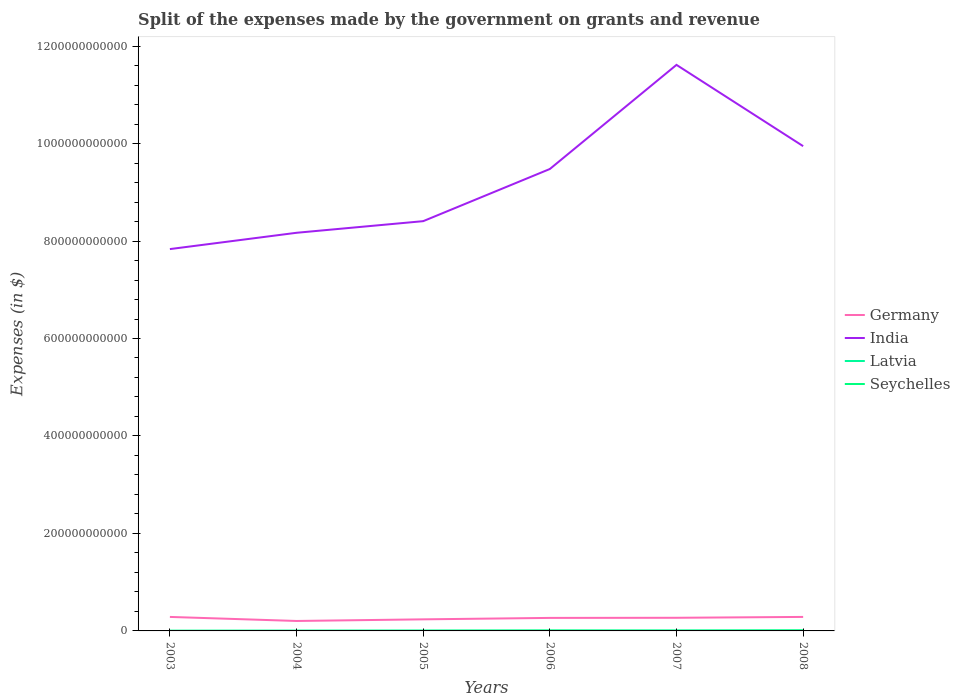Across all years, what is the maximum expenses made by the government on grants and revenue in India?
Provide a short and direct response. 7.83e+11. What is the total expenses made by the government on grants and revenue in Germany in the graph?
Your response must be concise. -4.98e+09. What is the difference between the highest and the second highest expenses made by the government on grants and revenue in India?
Offer a very short reply. 3.78e+11. What is the difference between the highest and the lowest expenses made by the government on grants and revenue in India?
Your answer should be very brief. 3. Is the expenses made by the government on grants and revenue in India strictly greater than the expenses made by the government on grants and revenue in Germany over the years?
Your answer should be compact. No. How many lines are there?
Provide a short and direct response. 4. How many years are there in the graph?
Make the answer very short. 6. What is the difference between two consecutive major ticks on the Y-axis?
Your answer should be compact. 2.00e+11. Where does the legend appear in the graph?
Offer a very short reply. Center right. How many legend labels are there?
Your response must be concise. 4. What is the title of the graph?
Keep it short and to the point. Split of the expenses made by the government on grants and revenue. What is the label or title of the Y-axis?
Your answer should be compact. Expenses (in $). What is the Expenses (in $) of Germany in 2003?
Make the answer very short. 2.87e+1. What is the Expenses (in $) in India in 2003?
Ensure brevity in your answer.  7.83e+11. What is the Expenses (in $) of Latvia in 2003?
Make the answer very short. 2.52e+08. What is the Expenses (in $) in Seychelles in 2003?
Give a very brief answer. 2.39e+08. What is the Expenses (in $) in Germany in 2004?
Offer a terse response. 2.04e+1. What is the Expenses (in $) in India in 2004?
Provide a succinct answer. 8.17e+11. What is the Expenses (in $) of Latvia in 2004?
Keep it short and to the point. 4.03e+08. What is the Expenses (in $) of Seychelles in 2004?
Offer a terse response. 2.82e+08. What is the Expenses (in $) of Germany in 2005?
Ensure brevity in your answer.  2.37e+1. What is the Expenses (in $) in India in 2005?
Provide a succinct answer. 8.41e+11. What is the Expenses (in $) of Latvia in 2005?
Offer a terse response. 5.18e+08. What is the Expenses (in $) of Seychelles in 2005?
Offer a terse response. 4.19e+08. What is the Expenses (in $) of Germany in 2006?
Offer a very short reply. 2.67e+1. What is the Expenses (in $) of India in 2006?
Make the answer very short. 9.48e+11. What is the Expenses (in $) in Latvia in 2006?
Keep it short and to the point. 5.75e+08. What is the Expenses (in $) in Seychelles in 2006?
Provide a short and direct response. 8.11e+08. What is the Expenses (in $) in Germany in 2007?
Your response must be concise. 2.70e+1. What is the Expenses (in $) of India in 2007?
Make the answer very short. 1.16e+12. What is the Expenses (in $) in Latvia in 2007?
Provide a short and direct response. 8.10e+08. What is the Expenses (in $) of Seychelles in 2007?
Keep it short and to the point. 4.27e+08. What is the Expenses (in $) in Germany in 2008?
Offer a terse response. 2.87e+1. What is the Expenses (in $) of India in 2008?
Provide a short and direct response. 9.95e+11. What is the Expenses (in $) in Latvia in 2008?
Provide a short and direct response. 8.22e+08. What is the Expenses (in $) in Seychelles in 2008?
Offer a very short reply. 1.01e+09. Across all years, what is the maximum Expenses (in $) of Germany?
Offer a terse response. 2.87e+1. Across all years, what is the maximum Expenses (in $) in India?
Your response must be concise. 1.16e+12. Across all years, what is the maximum Expenses (in $) of Latvia?
Your answer should be compact. 8.22e+08. Across all years, what is the maximum Expenses (in $) in Seychelles?
Make the answer very short. 1.01e+09. Across all years, what is the minimum Expenses (in $) of Germany?
Keep it short and to the point. 2.04e+1. Across all years, what is the minimum Expenses (in $) in India?
Keep it short and to the point. 7.83e+11. Across all years, what is the minimum Expenses (in $) of Latvia?
Ensure brevity in your answer.  2.52e+08. Across all years, what is the minimum Expenses (in $) in Seychelles?
Provide a succinct answer. 2.39e+08. What is the total Expenses (in $) of Germany in the graph?
Give a very brief answer. 1.55e+11. What is the total Expenses (in $) in India in the graph?
Give a very brief answer. 5.54e+12. What is the total Expenses (in $) of Latvia in the graph?
Offer a very short reply. 3.38e+09. What is the total Expenses (in $) in Seychelles in the graph?
Ensure brevity in your answer.  3.19e+09. What is the difference between the Expenses (in $) in Germany in 2003 and that in 2004?
Give a very brief answer. 8.29e+09. What is the difference between the Expenses (in $) of India in 2003 and that in 2004?
Your answer should be very brief. -3.34e+1. What is the difference between the Expenses (in $) of Latvia in 2003 and that in 2004?
Make the answer very short. -1.51e+08. What is the difference between the Expenses (in $) in Seychelles in 2003 and that in 2004?
Make the answer very short. -4.30e+07. What is the difference between the Expenses (in $) in Germany in 2003 and that in 2005?
Your answer should be compact. 4.98e+09. What is the difference between the Expenses (in $) in India in 2003 and that in 2005?
Make the answer very short. -5.73e+1. What is the difference between the Expenses (in $) in Latvia in 2003 and that in 2005?
Ensure brevity in your answer.  -2.65e+08. What is the difference between the Expenses (in $) of Seychelles in 2003 and that in 2005?
Your answer should be compact. -1.80e+08. What is the difference between the Expenses (in $) in Germany in 2003 and that in 2006?
Your answer should be compact. 2.01e+09. What is the difference between the Expenses (in $) in India in 2003 and that in 2006?
Offer a very short reply. -1.64e+11. What is the difference between the Expenses (in $) of Latvia in 2003 and that in 2006?
Provide a short and direct response. -3.23e+08. What is the difference between the Expenses (in $) of Seychelles in 2003 and that in 2006?
Your answer should be compact. -5.72e+08. What is the difference between the Expenses (in $) in Germany in 2003 and that in 2007?
Provide a short and direct response. 1.77e+09. What is the difference between the Expenses (in $) in India in 2003 and that in 2007?
Offer a very short reply. -3.78e+11. What is the difference between the Expenses (in $) of Latvia in 2003 and that in 2007?
Ensure brevity in your answer.  -5.57e+08. What is the difference between the Expenses (in $) of Seychelles in 2003 and that in 2007?
Offer a terse response. -1.88e+08. What is the difference between the Expenses (in $) of India in 2003 and that in 2008?
Your response must be concise. -2.11e+11. What is the difference between the Expenses (in $) in Latvia in 2003 and that in 2008?
Your response must be concise. -5.70e+08. What is the difference between the Expenses (in $) of Seychelles in 2003 and that in 2008?
Your answer should be very brief. -7.74e+08. What is the difference between the Expenses (in $) in Germany in 2004 and that in 2005?
Provide a succinct answer. -3.31e+09. What is the difference between the Expenses (in $) of India in 2004 and that in 2005?
Your answer should be very brief. -2.38e+1. What is the difference between the Expenses (in $) in Latvia in 2004 and that in 2005?
Your response must be concise. -1.14e+08. What is the difference between the Expenses (in $) in Seychelles in 2004 and that in 2005?
Your answer should be very brief. -1.37e+08. What is the difference between the Expenses (in $) in Germany in 2004 and that in 2006?
Your answer should be very brief. -6.28e+09. What is the difference between the Expenses (in $) of India in 2004 and that in 2006?
Keep it short and to the point. -1.31e+11. What is the difference between the Expenses (in $) in Latvia in 2004 and that in 2006?
Keep it short and to the point. -1.72e+08. What is the difference between the Expenses (in $) in Seychelles in 2004 and that in 2006?
Make the answer very short. -5.29e+08. What is the difference between the Expenses (in $) of Germany in 2004 and that in 2007?
Ensure brevity in your answer.  -6.52e+09. What is the difference between the Expenses (in $) of India in 2004 and that in 2007?
Make the answer very short. -3.45e+11. What is the difference between the Expenses (in $) in Latvia in 2004 and that in 2007?
Give a very brief answer. -4.06e+08. What is the difference between the Expenses (in $) in Seychelles in 2004 and that in 2007?
Provide a succinct answer. -1.45e+08. What is the difference between the Expenses (in $) in Germany in 2004 and that in 2008?
Ensure brevity in your answer.  -8.29e+09. What is the difference between the Expenses (in $) in India in 2004 and that in 2008?
Keep it short and to the point. -1.78e+11. What is the difference between the Expenses (in $) in Latvia in 2004 and that in 2008?
Provide a succinct answer. -4.19e+08. What is the difference between the Expenses (in $) of Seychelles in 2004 and that in 2008?
Ensure brevity in your answer.  -7.31e+08. What is the difference between the Expenses (in $) of Germany in 2005 and that in 2006?
Ensure brevity in your answer.  -2.97e+09. What is the difference between the Expenses (in $) in India in 2005 and that in 2006?
Keep it short and to the point. -1.07e+11. What is the difference between the Expenses (in $) in Latvia in 2005 and that in 2006?
Offer a very short reply. -5.76e+07. What is the difference between the Expenses (in $) of Seychelles in 2005 and that in 2006?
Your answer should be very brief. -3.92e+08. What is the difference between the Expenses (in $) of Germany in 2005 and that in 2007?
Make the answer very short. -3.21e+09. What is the difference between the Expenses (in $) of India in 2005 and that in 2007?
Your answer should be compact. -3.21e+11. What is the difference between the Expenses (in $) of Latvia in 2005 and that in 2007?
Provide a short and direct response. -2.92e+08. What is the difference between the Expenses (in $) in Seychelles in 2005 and that in 2007?
Your answer should be compact. -7.91e+06. What is the difference between the Expenses (in $) of Germany in 2005 and that in 2008?
Give a very brief answer. -4.98e+09. What is the difference between the Expenses (in $) in India in 2005 and that in 2008?
Offer a terse response. -1.54e+11. What is the difference between the Expenses (in $) in Latvia in 2005 and that in 2008?
Make the answer very short. -3.04e+08. What is the difference between the Expenses (in $) in Seychelles in 2005 and that in 2008?
Your answer should be very brief. -5.94e+08. What is the difference between the Expenses (in $) of Germany in 2006 and that in 2007?
Your response must be concise. -2.40e+08. What is the difference between the Expenses (in $) of India in 2006 and that in 2007?
Keep it short and to the point. -2.14e+11. What is the difference between the Expenses (in $) of Latvia in 2006 and that in 2007?
Provide a short and direct response. -2.34e+08. What is the difference between the Expenses (in $) in Seychelles in 2006 and that in 2007?
Provide a short and direct response. 3.84e+08. What is the difference between the Expenses (in $) in Germany in 2006 and that in 2008?
Make the answer very short. -2.01e+09. What is the difference between the Expenses (in $) in India in 2006 and that in 2008?
Give a very brief answer. -4.69e+1. What is the difference between the Expenses (in $) of Latvia in 2006 and that in 2008?
Offer a terse response. -2.47e+08. What is the difference between the Expenses (in $) of Seychelles in 2006 and that in 2008?
Provide a succinct answer. -2.02e+08. What is the difference between the Expenses (in $) in Germany in 2007 and that in 2008?
Your answer should be very brief. -1.77e+09. What is the difference between the Expenses (in $) of India in 2007 and that in 2008?
Your answer should be compact. 1.67e+11. What is the difference between the Expenses (in $) in Latvia in 2007 and that in 2008?
Ensure brevity in your answer.  -1.25e+07. What is the difference between the Expenses (in $) of Seychelles in 2007 and that in 2008?
Provide a short and direct response. -5.86e+08. What is the difference between the Expenses (in $) in Germany in 2003 and the Expenses (in $) in India in 2004?
Offer a very short reply. -7.88e+11. What is the difference between the Expenses (in $) of Germany in 2003 and the Expenses (in $) of Latvia in 2004?
Your answer should be compact. 2.83e+1. What is the difference between the Expenses (in $) in Germany in 2003 and the Expenses (in $) in Seychelles in 2004?
Provide a short and direct response. 2.84e+1. What is the difference between the Expenses (in $) of India in 2003 and the Expenses (in $) of Latvia in 2004?
Your answer should be very brief. 7.83e+11. What is the difference between the Expenses (in $) of India in 2003 and the Expenses (in $) of Seychelles in 2004?
Provide a short and direct response. 7.83e+11. What is the difference between the Expenses (in $) of Latvia in 2003 and the Expenses (in $) of Seychelles in 2004?
Make the answer very short. -2.95e+07. What is the difference between the Expenses (in $) of Germany in 2003 and the Expenses (in $) of India in 2005?
Offer a very short reply. -8.12e+11. What is the difference between the Expenses (in $) of Germany in 2003 and the Expenses (in $) of Latvia in 2005?
Make the answer very short. 2.82e+1. What is the difference between the Expenses (in $) of Germany in 2003 and the Expenses (in $) of Seychelles in 2005?
Keep it short and to the point. 2.83e+1. What is the difference between the Expenses (in $) in India in 2003 and the Expenses (in $) in Latvia in 2005?
Offer a very short reply. 7.83e+11. What is the difference between the Expenses (in $) of India in 2003 and the Expenses (in $) of Seychelles in 2005?
Offer a terse response. 7.83e+11. What is the difference between the Expenses (in $) in Latvia in 2003 and the Expenses (in $) in Seychelles in 2005?
Provide a succinct answer. -1.66e+08. What is the difference between the Expenses (in $) of Germany in 2003 and the Expenses (in $) of India in 2006?
Provide a short and direct response. -9.19e+11. What is the difference between the Expenses (in $) of Germany in 2003 and the Expenses (in $) of Latvia in 2006?
Your answer should be compact. 2.81e+1. What is the difference between the Expenses (in $) of Germany in 2003 and the Expenses (in $) of Seychelles in 2006?
Give a very brief answer. 2.79e+1. What is the difference between the Expenses (in $) in India in 2003 and the Expenses (in $) in Latvia in 2006?
Ensure brevity in your answer.  7.83e+11. What is the difference between the Expenses (in $) of India in 2003 and the Expenses (in $) of Seychelles in 2006?
Keep it short and to the point. 7.83e+11. What is the difference between the Expenses (in $) in Latvia in 2003 and the Expenses (in $) in Seychelles in 2006?
Your response must be concise. -5.59e+08. What is the difference between the Expenses (in $) of Germany in 2003 and the Expenses (in $) of India in 2007?
Your answer should be compact. -1.13e+12. What is the difference between the Expenses (in $) of Germany in 2003 and the Expenses (in $) of Latvia in 2007?
Offer a terse response. 2.79e+1. What is the difference between the Expenses (in $) in Germany in 2003 and the Expenses (in $) in Seychelles in 2007?
Offer a terse response. 2.83e+1. What is the difference between the Expenses (in $) in India in 2003 and the Expenses (in $) in Latvia in 2007?
Make the answer very short. 7.83e+11. What is the difference between the Expenses (in $) of India in 2003 and the Expenses (in $) of Seychelles in 2007?
Keep it short and to the point. 7.83e+11. What is the difference between the Expenses (in $) of Latvia in 2003 and the Expenses (in $) of Seychelles in 2007?
Provide a succinct answer. -1.74e+08. What is the difference between the Expenses (in $) in Germany in 2003 and the Expenses (in $) in India in 2008?
Give a very brief answer. -9.66e+11. What is the difference between the Expenses (in $) in Germany in 2003 and the Expenses (in $) in Latvia in 2008?
Provide a short and direct response. 2.79e+1. What is the difference between the Expenses (in $) of Germany in 2003 and the Expenses (in $) of Seychelles in 2008?
Offer a very short reply. 2.77e+1. What is the difference between the Expenses (in $) in India in 2003 and the Expenses (in $) in Latvia in 2008?
Offer a terse response. 7.83e+11. What is the difference between the Expenses (in $) of India in 2003 and the Expenses (in $) of Seychelles in 2008?
Offer a very short reply. 7.82e+11. What is the difference between the Expenses (in $) in Latvia in 2003 and the Expenses (in $) in Seychelles in 2008?
Give a very brief answer. -7.61e+08. What is the difference between the Expenses (in $) of Germany in 2004 and the Expenses (in $) of India in 2005?
Your response must be concise. -8.20e+11. What is the difference between the Expenses (in $) in Germany in 2004 and the Expenses (in $) in Latvia in 2005?
Provide a succinct answer. 1.99e+1. What is the difference between the Expenses (in $) of Germany in 2004 and the Expenses (in $) of Seychelles in 2005?
Your response must be concise. 2.00e+1. What is the difference between the Expenses (in $) of India in 2004 and the Expenses (in $) of Latvia in 2005?
Make the answer very short. 8.16e+11. What is the difference between the Expenses (in $) of India in 2004 and the Expenses (in $) of Seychelles in 2005?
Offer a very short reply. 8.16e+11. What is the difference between the Expenses (in $) in Latvia in 2004 and the Expenses (in $) in Seychelles in 2005?
Offer a terse response. -1.53e+07. What is the difference between the Expenses (in $) of Germany in 2004 and the Expenses (in $) of India in 2006?
Ensure brevity in your answer.  -9.27e+11. What is the difference between the Expenses (in $) of Germany in 2004 and the Expenses (in $) of Latvia in 2006?
Your answer should be compact. 1.99e+1. What is the difference between the Expenses (in $) of Germany in 2004 and the Expenses (in $) of Seychelles in 2006?
Make the answer very short. 1.96e+1. What is the difference between the Expenses (in $) of India in 2004 and the Expenses (in $) of Latvia in 2006?
Give a very brief answer. 8.16e+11. What is the difference between the Expenses (in $) of India in 2004 and the Expenses (in $) of Seychelles in 2006?
Give a very brief answer. 8.16e+11. What is the difference between the Expenses (in $) of Latvia in 2004 and the Expenses (in $) of Seychelles in 2006?
Keep it short and to the point. -4.08e+08. What is the difference between the Expenses (in $) of Germany in 2004 and the Expenses (in $) of India in 2007?
Ensure brevity in your answer.  -1.14e+12. What is the difference between the Expenses (in $) of Germany in 2004 and the Expenses (in $) of Latvia in 2007?
Your answer should be very brief. 1.96e+1. What is the difference between the Expenses (in $) of Germany in 2004 and the Expenses (in $) of Seychelles in 2007?
Your response must be concise. 2.00e+1. What is the difference between the Expenses (in $) in India in 2004 and the Expenses (in $) in Latvia in 2007?
Offer a terse response. 8.16e+11. What is the difference between the Expenses (in $) of India in 2004 and the Expenses (in $) of Seychelles in 2007?
Make the answer very short. 8.16e+11. What is the difference between the Expenses (in $) of Latvia in 2004 and the Expenses (in $) of Seychelles in 2007?
Your answer should be compact. -2.32e+07. What is the difference between the Expenses (in $) of Germany in 2004 and the Expenses (in $) of India in 2008?
Provide a short and direct response. -9.74e+11. What is the difference between the Expenses (in $) of Germany in 2004 and the Expenses (in $) of Latvia in 2008?
Offer a terse response. 1.96e+1. What is the difference between the Expenses (in $) of Germany in 2004 and the Expenses (in $) of Seychelles in 2008?
Your answer should be compact. 1.94e+1. What is the difference between the Expenses (in $) of India in 2004 and the Expenses (in $) of Latvia in 2008?
Your answer should be compact. 8.16e+11. What is the difference between the Expenses (in $) in India in 2004 and the Expenses (in $) in Seychelles in 2008?
Offer a very short reply. 8.16e+11. What is the difference between the Expenses (in $) in Latvia in 2004 and the Expenses (in $) in Seychelles in 2008?
Your answer should be compact. -6.09e+08. What is the difference between the Expenses (in $) in Germany in 2005 and the Expenses (in $) in India in 2006?
Give a very brief answer. -9.24e+11. What is the difference between the Expenses (in $) in Germany in 2005 and the Expenses (in $) in Latvia in 2006?
Give a very brief answer. 2.32e+1. What is the difference between the Expenses (in $) in Germany in 2005 and the Expenses (in $) in Seychelles in 2006?
Your answer should be compact. 2.29e+1. What is the difference between the Expenses (in $) in India in 2005 and the Expenses (in $) in Latvia in 2006?
Your response must be concise. 8.40e+11. What is the difference between the Expenses (in $) of India in 2005 and the Expenses (in $) of Seychelles in 2006?
Make the answer very short. 8.40e+11. What is the difference between the Expenses (in $) in Latvia in 2005 and the Expenses (in $) in Seychelles in 2006?
Offer a very short reply. -2.93e+08. What is the difference between the Expenses (in $) of Germany in 2005 and the Expenses (in $) of India in 2007?
Give a very brief answer. -1.14e+12. What is the difference between the Expenses (in $) in Germany in 2005 and the Expenses (in $) in Latvia in 2007?
Provide a succinct answer. 2.29e+1. What is the difference between the Expenses (in $) in Germany in 2005 and the Expenses (in $) in Seychelles in 2007?
Make the answer very short. 2.33e+1. What is the difference between the Expenses (in $) in India in 2005 and the Expenses (in $) in Latvia in 2007?
Make the answer very short. 8.40e+11. What is the difference between the Expenses (in $) of India in 2005 and the Expenses (in $) of Seychelles in 2007?
Keep it short and to the point. 8.40e+11. What is the difference between the Expenses (in $) in Latvia in 2005 and the Expenses (in $) in Seychelles in 2007?
Ensure brevity in your answer.  9.10e+07. What is the difference between the Expenses (in $) in Germany in 2005 and the Expenses (in $) in India in 2008?
Provide a succinct answer. -9.71e+11. What is the difference between the Expenses (in $) of Germany in 2005 and the Expenses (in $) of Latvia in 2008?
Make the answer very short. 2.29e+1. What is the difference between the Expenses (in $) in Germany in 2005 and the Expenses (in $) in Seychelles in 2008?
Give a very brief answer. 2.27e+1. What is the difference between the Expenses (in $) in India in 2005 and the Expenses (in $) in Latvia in 2008?
Your answer should be very brief. 8.40e+11. What is the difference between the Expenses (in $) in India in 2005 and the Expenses (in $) in Seychelles in 2008?
Your answer should be very brief. 8.40e+11. What is the difference between the Expenses (in $) of Latvia in 2005 and the Expenses (in $) of Seychelles in 2008?
Give a very brief answer. -4.95e+08. What is the difference between the Expenses (in $) of Germany in 2006 and the Expenses (in $) of India in 2007?
Provide a succinct answer. -1.13e+12. What is the difference between the Expenses (in $) of Germany in 2006 and the Expenses (in $) of Latvia in 2007?
Your response must be concise. 2.59e+1. What is the difference between the Expenses (in $) in Germany in 2006 and the Expenses (in $) in Seychelles in 2007?
Your response must be concise. 2.63e+1. What is the difference between the Expenses (in $) in India in 2006 and the Expenses (in $) in Latvia in 2007?
Make the answer very short. 9.47e+11. What is the difference between the Expenses (in $) of India in 2006 and the Expenses (in $) of Seychelles in 2007?
Provide a short and direct response. 9.47e+11. What is the difference between the Expenses (in $) in Latvia in 2006 and the Expenses (in $) in Seychelles in 2007?
Your answer should be compact. 1.49e+08. What is the difference between the Expenses (in $) of Germany in 2006 and the Expenses (in $) of India in 2008?
Provide a succinct answer. -9.68e+11. What is the difference between the Expenses (in $) of Germany in 2006 and the Expenses (in $) of Latvia in 2008?
Give a very brief answer. 2.59e+1. What is the difference between the Expenses (in $) in Germany in 2006 and the Expenses (in $) in Seychelles in 2008?
Make the answer very short. 2.57e+1. What is the difference between the Expenses (in $) of India in 2006 and the Expenses (in $) of Latvia in 2008?
Keep it short and to the point. 9.47e+11. What is the difference between the Expenses (in $) of India in 2006 and the Expenses (in $) of Seychelles in 2008?
Your answer should be compact. 9.47e+11. What is the difference between the Expenses (in $) in Latvia in 2006 and the Expenses (in $) in Seychelles in 2008?
Keep it short and to the point. -4.38e+08. What is the difference between the Expenses (in $) of Germany in 2007 and the Expenses (in $) of India in 2008?
Give a very brief answer. -9.68e+11. What is the difference between the Expenses (in $) of Germany in 2007 and the Expenses (in $) of Latvia in 2008?
Provide a succinct answer. 2.61e+1. What is the difference between the Expenses (in $) in Germany in 2007 and the Expenses (in $) in Seychelles in 2008?
Provide a succinct answer. 2.59e+1. What is the difference between the Expenses (in $) of India in 2007 and the Expenses (in $) of Latvia in 2008?
Keep it short and to the point. 1.16e+12. What is the difference between the Expenses (in $) of India in 2007 and the Expenses (in $) of Seychelles in 2008?
Give a very brief answer. 1.16e+12. What is the difference between the Expenses (in $) of Latvia in 2007 and the Expenses (in $) of Seychelles in 2008?
Provide a short and direct response. -2.03e+08. What is the average Expenses (in $) of Germany per year?
Your answer should be compact. 2.59e+1. What is the average Expenses (in $) in India per year?
Provide a short and direct response. 9.24e+11. What is the average Expenses (in $) in Latvia per year?
Your answer should be very brief. 5.63e+08. What is the average Expenses (in $) of Seychelles per year?
Offer a terse response. 5.32e+08. In the year 2003, what is the difference between the Expenses (in $) of Germany and Expenses (in $) of India?
Give a very brief answer. -7.55e+11. In the year 2003, what is the difference between the Expenses (in $) in Germany and Expenses (in $) in Latvia?
Offer a very short reply. 2.85e+1. In the year 2003, what is the difference between the Expenses (in $) in Germany and Expenses (in $) in Seychelles?
Give a very brief answer. 2.85e+1. In the year 2003, what is the difference between the Expenses (in $) in India and Expenses (in $) in Latvia?
Your response must be concise. 7.83e+11. In the year 2003, what is the difference between the Expenses (in $) in India and Expenses (in $) in Seychelles?
Your response must be concise. 7.83e+11. In the year 2003, what is the difference between the Expenses (in $) in Latvia and Expenses (in $) in Seychelles?
Your answer should be compact. 1.35e+07. In the year 2004, what is the difference between the Expenses (in $) in Germany and Expenses (in $) in India?
Make the answer very short. -7.96e+11. In the year 2004, what is the difference between the Expenses (in $) in Germany and Expenses (in $) in Latvia?
Your response must be concise. 2.00e+1. In the year 2004, what is the difference between the Expenses (in $) of Germany and Expenses (in $) of Seychelles?
Provide a succinct answer. 2.01e+1. In the year 2004, what is the difference between the Expenses (in $) in India and Expenses (in $) in Latvia?
Provide a short and direct response. 8.17e+11. In the year 2004, what is the difference between the Expenses (in $) in India and Expenses (in $) in Seychelles?
Keep it short and to the point. 8.17e+11. In the year 2004, what is the difference between the Expenses (in $) in Latvia and Expenses (in $) in Seychelles?
Offer a very short reply. 1.22e+08. In the year 2005, what is the difference between the Expenses (in $) in Germany and Expenses (in $) in India?
Provide a short and direct response. -8.17e+11. In the year 2005, what is the difference between the Expenses (in $) in Germany and Expenses (in $) in Latvia?
Keep it short and to the point. 2.32e+1. In the year 2005, what is the difference between the Expenses (in $) in Germany and Expenses (in $) in Seychelles?
Offer a terse response. 2.33e+1. In the year 2005, what is the difference between the Expenses (in $) of India and Expenses (in $) of Latvia?
Provide a short and direct response. 8.40e+11. In the year 2005, what is the difference between the Expenses (in $) in India and Expenses (in $) in Seychelles?
Your answer should be compact. 8.40e+11. In the year 2005, what is the difference between the Expenses (in $) of Latvia and Expenses (in $) of Seychelles?
Make the answer very short. 9.89e+07. In the year 2006, what is the difference between the Expenses (in $) in Germany and Expenses (in $) in India?
Your response must be concise. -9.21e+11. In the year 2006, what is the difference between the Expenses (in $) in Germany and Expenses (in $) in Latvia?
Give a very brief answer. 2.61e+1. In the year 2006, what is the difference between the Expenses (in $) in Germany and Expenses (in $) in Seychelles?
Your response must be concise. 2.59e+1. In the year 2006, what is the difference between the Expenses (in $) of India and Expenses (in $) of Latvia?
Your answer should be compact. 9.47e+11. In the year 2006, what is the difference between the Expenses (in $) of India and Expenses (in $) of Seychelles?
Provide a short and direct response. 9.47e+11. In the year 2006, what is the difference between the Expenses (in $) of Latvia and Expenses (in $) of Seychelles?
Make the answer very short. -2.36e+08. In the year 2007, what is the difference between the Expenses (in $) of Germany and Expenses (in $) of India?
Make the answer very short. -1.13e+12. In the year 2007, what is the difference between the Expenses (in $) of Germany and Expenses (in $) of Latvia?
Your answer should be compact. 2.61e+1. In the year 2007, what is the difference between the Expenses (in $) in Germany and Expenses (in $) in Seychelles?
Your answer should be very brief. 2.65e+1. In the year 2007, what is the difference between the Expenses (in $) in India and Expenses (in $) in Latvia?
Provide a short and direct response. 1.16e+12. In the year 2007, what is the difference between the Expenses (in $) of India and Expenses (in $) of Seychelles?
Provide a short and direct response. 1.16e+12. In the year 2007, what is the difference between the Expenses (in $) of Latvia and Expenses (in $) of Seychelles?
Offer a very short reply. 3.83e+08. In the year 2008, what is the difference between the Expenses (in $) in Germany and Expenses (in $) in India?
Give a very brief answer. -9.66e+11. In the year 2008, what is the difference between the Expenses (in $) in Germany and Expenses (in $) in Latvia?
Your response must be concise. 2.79e+1. In the year 2008, what is the difference between the Expenses (in $) in Germany and Expenses (in $) in Seychelles?
Your answer should be compact. 2.77e+1. In the year 2008, what is the difference between the Expenses (in $) of India and Expenses (in $) of Latvia?
Your answer should be very brief. 9.94e+11. In the year 2008, what is the difference between the Expenses (in $) of India and Expenses (in $) of Seychelles?
Offer a very short reply. 9.94e+11. In the year 2008, what is the difference between the Expenses (in $) in Latvia and Expenses (in $) in Seychelles?
Your answer should be very brief. -1.91e+08. What is the ratio of the Expenses (in $) in Germany in 2003 to that in 2004?
Offer a terse response. 1.41. What is the ratio of the Expenses (in $) in India in 2003 to that in 2004?
Offer a terse response. 0.96. What is the ratio of the Expenses (in $) of Latvia in 2003 to that in 2004?
Provide a short and direct response. 0.63. What is the ratio of the Expenses (in $) of Seychelles in 2003 to that in 2004?
Give a very brief answer. 0.85. What is the ratio of the Expenses (in $) in Germany in 2003 to that in 2005?
Offer a very short reply. 1.21. What is the ratio of the Expenses (in $) of India in 2003 to that in 2005?
Offer a very short reply. 0.93. What is the ratio of the Expenses (in $) in Latvia in 2003 to that in 2005?
Your response must be concise. 0.49. What is the ratio of the Expenses (in $) in Seychelles in 2003 to that in 2005?
Make the answer very short. 0.57. What is the ratio of the Expenses (in $) of Germany in 2003 to that in 2006?
Your response must be concise. 1.08. What is the ratio of the Expenses (in $) of India in 2003 to that in 2006?
Provide a short and direct response. 0.83. What is the ratio of the Expenses (in $) in Latvia in 2003 to that in 2006?
Keep it short and to the point. 0.44. What is the ratio of the Expenses (in $) of Seychelles in 2003 to that in 2006?
Provide a succinct answer. 0.29. What is the ratio of the Expenses (in $) in Germany in 2003 to that in 2007?
Provide a succinct answer. 1.07. What is the ratio of the Expenses (in $) of India in 2003 to that in 2007?
Provide a short and direct response. 0.67. What is the ratio of the Expenses (in $) of Latvia in 2003 to that in 2007?
Provide a succinct answer. 0.31. What is the ratio of the Expenses (in $) in Seychelles in 2003 to that in 2007?
Ensure brevity in your answer.  0.56. What is the ratio of the Expenses (in $) in India in 2003 to that in 2008?
Your answer should be compact. 0.79. What is the ratio of the Expenses (in $) in Latvia in 2003 to that in 2008?
Make the answer very short. 0.31. What is the ratio of the Expenses (in $) of Seychelles in 2003 to that in 2008?
Offer a very short reply. 0.24. What is the ratio of the Expenses (in $) of Germany in 2004 to that in 2005?
Your answer should be very brief. 0.86. What is the ratio of the Expenses (in $) of India in 2004 to that in 2005?
Provide a short and direct response. 0.97. What is the ratio of the Expenses (in $) in Latvia in 2004 to that in 2005?
Provide a succinct answer. 0.78. What is the ratio of the Expenses (in $) in Seychelles in 2004 to that in 2005?
Your response must be concise. 0.67. What is the ratio of the Expenses (in $) of Germany in 2004 to that in 2006?
Provide a short and direct response. 0.76. What is the ratio of the Expenses (in $) of India in 2004 to that in 2006?
Offer a very short reply. 0.86. What is the ratio of the Expenses (in $) in Latvia in 2004 to that in 2006?
Provide a succinct answer. 0.7. What is the ratio of the Expenses (in $) in Seychelles in 2004 to that in 2006?
Give a very brief answer. 0.35. What is the ratio of the Expenses (in $) of Germany in 2004 to that in 2007?
Your response must be concise. 0.76. What is the ratio of the Expenses (in $) in India in 2004 to that in 2007?
Offer a terse response. 0.7. What is the ratio of the Expenses (in $) of Latvia in 2004 to that in 2007?
Offer a very short reply. 0.5. What is the ratio of the Expenses (in $) in Seychelles in 2004 to that in 2007?
Your answer should be compact. 0.66. What is the ratio of the Expenses (in $) of Germany in 2004 to that in 2008?
Your answer should be very brief. 0.71. What is the ratio of the Expenses (in $) in India in 2004 to that in 2008?
Make the answer very short. 0.82. What is the ratio of the Expenses (in $) in Latvia in 2004 to that in 2008?
Give a very brief answer. 0.49. What is the ratio of the Expenses (in $) of Seychelles in 2004 to that in 2008?
Provide a short and direct response. 0.28. What is the ratio of the Expenses (in $) of Germany in 2005 to that in 2006?
Your answer should be very brief. 0.89. What is the ratio of the Expenses (in $) in India in 2005 to that in 2006?
Ensure brevity in your answer.  0.89. What is the ratio of the Expenses (in $) of Latvia in 2005 to that in 2006?
Offer a terse response. 0.9. What is the ratio of the Expenses (in $) in Seychelles in 2005 to that in 2006?
Provide a succinct answer. 0.52. What is the ratio of the Expenses (in $) in Germany in 2005 to that in 2007?
Ensure brevity in your answer.  0.88. What is the ratio of the Expenses (in $) of India in 2005 to that in 2007?
Make the answer very short. 0.72. What is the ratio of the Expenses (in $) of Latvia in 2005 to that in 2007?
Ensure brevity in your answer.  0.64. What is the ratio of the Expenses (in $) in Seychelles in 2005 to that in 2007?
Keep it short and to the point. 0.98. What is the ratio of the Expenses (in $) of Germany in 2005 to that in 2008?
Your answer should be compact. 0.83. What is the ratio of the Expenses (in $) in India in 2005 to that in 2008?
Provide a short and direct response. 0.85. What is the ratio of the Expenses (in $) of Latvia in 2005 to that in 2008?
Your answer should be very brief. 0.63. What is the ratio of the Expenses (in $) of Seychelles in 2005 to that in 2008?
Your response must be concise. 0.41. What is the ratio of the Expenses (in $) in India in 2006 to that in 2007?
Offer a very short reply. 0.82. What is the ratio of the Expenses (in $) in Latvia in 2006 to that in 2007?
Keep it short and to the point. 0.71. What is the ratio of the Expenses (in $) in Seychelles in 2006 to that in 2007?
Your answer should be compact. 1.9. What is the ratio of the Expenses (in $) of Germany in 2006 to that in 2008?
Provide a short and direct response. 0.93. What is the ratio of the Expenses (in $) in India in 2006 to that in 2008?
Give a very brief answer. 0.95. What is the ratio of the Expenses (in $) of Latvia in 2006 to that in 2008?
Your response must be concise. 0.7. What is the ratio of the Expenses (in $) of Seychelles in 2006 to that in 2008?
Make the answer very short. 0.8. What is the ratio of the Expenses (in $) in Germany in 2007 to that in 2008?
Make the answer very short. 0.94. What is the ratio of the Expenses (in $) in India in 2007 to that in 2008?
Give a very brief answer. 1.17. What is the ratio of the Expenses (in $) of Latvia in 2007 to that in 2008?
Offer a terse response. 0.98. What is the ratio of the Expenses (in $) in Seychelles in 2007 to that in 2008?
Offer a very short reply. 0.42. What is the difference between the highest and the second highest Expenses (in $) of Germany?
Your answer should be very brief. 0. What is the difference between the highest and the second highest Expenses (in $) in India?
Keep it short and to the point. 1.67e+11. What is the difference between the highest and the second highest Expenses (in $) in Latvia?
Offer a very short reply. 1.25e+07. What is the difference between the highest and the second highest Expenses (in $) in Seychelles?
Provide a short and direct response. 2.02e+08. What is the difference between the highest and the lowest Expenses (in $) in Germany?
Offer a terse response. 8.29e+09. What is the difference between the highest and the lowest Expenses (in $) in India?
Provide a succinct answer. 3.78e+11. What is the difference between the highest and the lowest Expenses (in $) of Latvia?
Give a very brief answer. 5.70e+08. What is the difference between the highest and the lowest Expenses (in $) in Seychelles?
Provide a short and direct response. 7.74e+08. 